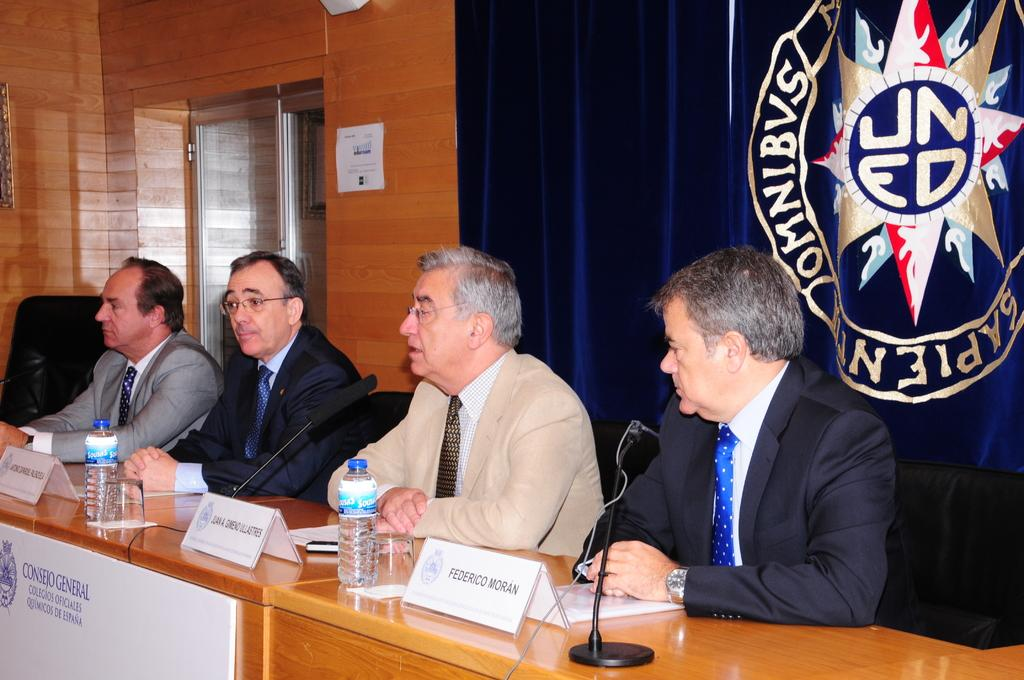<image>
Offer a succinct explanation of the picture presented. a few men including one with the name federico in front of them 